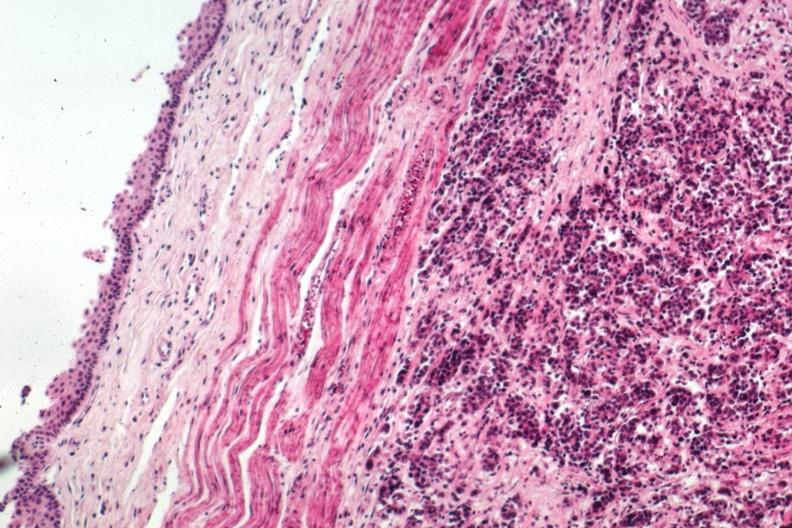s metastatic carcinoma breast present?
Answer the question using a single word or phrase. Yes 